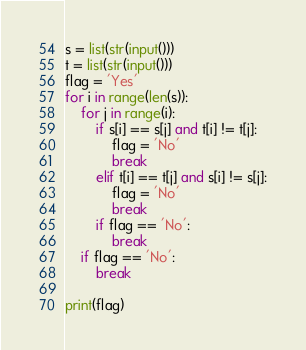Convert code to text. <code><loc_0><loc_0><loc_500><loc_500><_Python_>s = list(str(input()))
t = list(str(input()))
flag = 'Yes'
for i in range(len(s)):
    for j in range(i):
        if s[i] == s[j] and t[i] != t[j]:
            flag = 'No'
            break
        elif t[i] == t[j] and s[i] != s[j]:
            flag = 'No'
            break
        if flag == 'No':
            break
    if flag == 'No':
        break

print(flag)</code> 